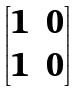Convert formula to latex. <formula><loc_0><loc_0><loc_500><loc_500>\begin{bmatrix} 1 & 0 \\ 1 & 0 \\ \end{bmatrix}</formula> 